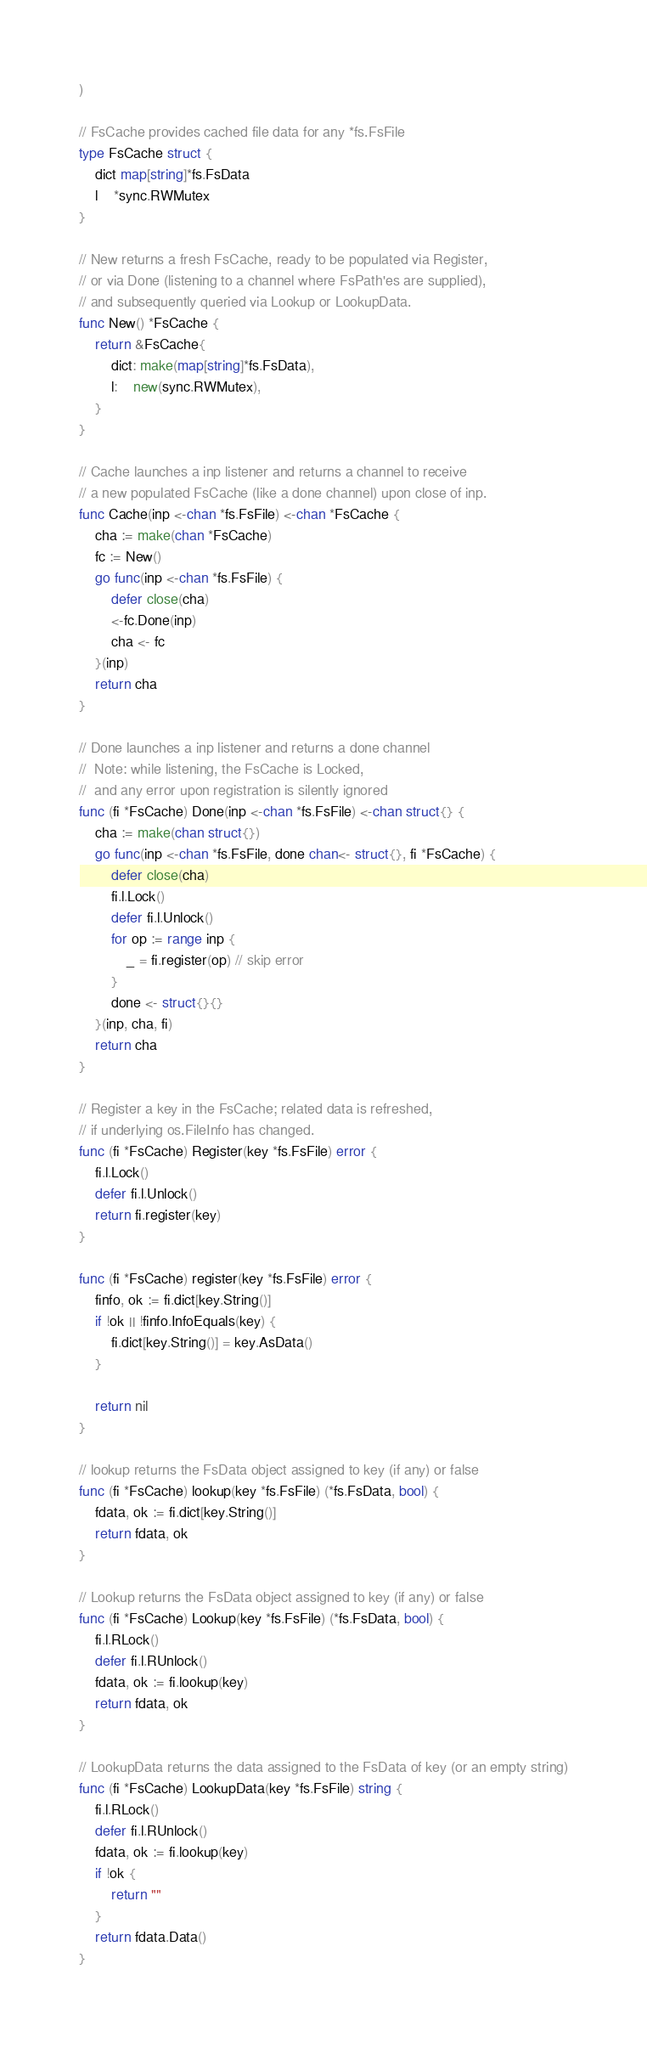<code> <loc_0><loc_0><loc_500><loc_500><_Go_>)

// FsCache provides cached file data for any *fs.FsFile
type FsCache struct {
	dict map[string]*fs.FsData
	l    *sync.RWMutex
}

// New returns a fresh FsCache, ready to be populated via Register,
// or via Done (listening to a channel where FsPath'es are supplied),
// and subsequently queried via Lookup or LookupData.
func New() *FsCache {
	return &FsCache{
		dict: make(map[string]*fs.FsData),
		l:    new(sync.RWMutex),
	}
}

// Cache launches a inp listener and returns a channel to receive
// a new populated FsCache (like a done channel) upon close of inp.
func Cache(inp <-chan *fs.FsFile) <-chan *FsCache {
	cha := make(chan *FsCache)
	fc := New()
	go func(inp <-chan *fs.FsFile) {
		defer close(cha)
		<-fc.Done(inp)
		cha <- fc
	}(inp)
	return cha
}

// Done launches a inp listener and returns a done channel
//  Note: while listening, the FsCache is Locked,
//  and any error upon registration is silently ignored
func (fi *FsCache) Done(inp <-chan *fs.FsFile) <-chan struct{} {
	cha := make(chan struct{})
	go func(inp <-chan *fs.FsFile, done chan<- struct{}, fi *FsCache) {
		defer close(cha)
		fi.l.Lock()
		defer fi.l.Unlock()
		for op := range inp {
			_ = fi.register(op) // skip error
		}
		done <- struct{}{}
	}(inp, cha, fi)
	return cha
}

// Register a key in the FsCache; related data is refreshed,
// if underlying os.FileInfo has changed.
func (fi *FsCache) Register(key *fs.FsFile) error {
	fi.l.Lock()
	defer fi.l.Unlock()
	return fi.register(key)
}

func (fi *FsCache) register(key *fs.FsFile) error {
	finfo, ok := fi.dict[key.String()]
	if !ok || !finfo.InfoEquals(key) {
		fi.dict[key.String()] = key.AsData()
	}

	return nil
}

// lookup returns the FsData object assigned to key (if any) or false
func (fi *FsCache) lookup(key *fs.FsFile) (*fs.FsData, bool) {
	fdata, ok := fi.dict[key.String()]
	return fdata, ok
}

// Lookup returns the FsData object assigned to key (if any) or false
func (fi *FsCache) Lookup(key *fs.FsFile) (*fs.FsData, bool) {
	fi.l.RLock()
	defer fi.l.RUnlock()
	fdata, ok := fi.lookup(key)
	return fdata, ok
}

// LookupData returns the data assigned to the FsData of key (or an empty string)
func (fi *FsCache) LookupData(key *fs.FsFile) string {
	fi.l.RLock()
	defer fi.l.RUnlock()
	fdata, ok := fi.lookup(key)
	if !ok {
		return ""
	}
	return fdata.Data()
}
</code> 